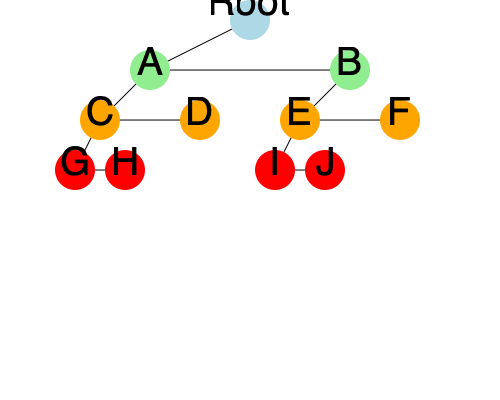Given the attack tree above, which represents potential vulnerabilities in a software system, calculate the total number of unique attack paths to compromise the root node. Assume that all leaf nodes (G, H, I, J) are equally likely to be exploited, and any successful path from a leaf to the root constitutes a valid attack. How does this analysis help in prioritizing vulnerability mitigation efforts? To solve this problem and understand its implications for vulnerability mitigation, let's follow these steps:

1. Identify the structure of the attack tree:
   - The root node represents the main system compromise.
   - Nodes A and B are the main branches.
   - Nodes C, D, E, and F are sub-branches.
   - Nodes G, H, I, and J are leaf nodes (potential entry points for attacks).

2. Count the unique paths from leaf nodes to the root:
   - Path 1: G → C → A → Root
   - Path 2: H → C → A → Root
   - Path 3: D → A → Root
   - Path 4: I → E → B → Root
   - Path 5: J → E → B → Root
   - Path 6: F → B → Root

3. Calculate the total number of unique attack paths:
   There are 6 unique paths from leaf nodes to the root.

4. Analyze the implications for vulnerability mitigation:
   a) Criticality of nodes:
      - Nodes A and B are critical as they are part of multiple attack paths.
      - Nodes C and E are secondary priorities as they each lead to two leaf nodes.
      - Nodes D and F are tertiary priorities as they each lead to only one attack path.

   b) Resource allocation:
      - Prioritize securing nodes A and B, as compromising either of these nodes opens up multiple attack vectors.
      - Next, focus on nodes C and E to protect against multiple leaf-level vulnerabilities.
      - Nodes D and F can be addressed with lower priority.

   c) Risk assessment:
      - The system has a balanced structure, with an equal number of paths through nodes A and B.
      - This suggests that both main branches (A and B) require equal attention in terms of security measures.

   d) Defense-in-depth strategy:
      - Implementing security measures at multiple levels (leaf, intermediate, and near-root nodes) can significantly reduce the risk of a successful attack reaching the root.

5. How this analysis helps in prioritizing vulnerability mitigation efforts:
   - It provides a clear visualization of potential attack vectors.
   - It helps identify the most critical nodes in the system that, if compromised, would have the greatest impact.
   - It allows for a systematic approach to resource allocation in security efforts.
   - It highlights the importance of addressing vulnerabilities at different levels of the system architecture.
   - It can guide the development of a comprehensive security strategy that addresses both high-level (near-root) and low-level (leaf) vulnerabilities.

By using this attack tree analysis, software developers can make informed decisions about where to focus their security efforts, potentially reducing the overall vulnerability of the system more efficiently than by addressing all potential vulnerabilities equally.
Answer: 6 unique attack paths; prioritizes critical nodes (A, B), guides resource allocation, and informs multi-level security strategy. 